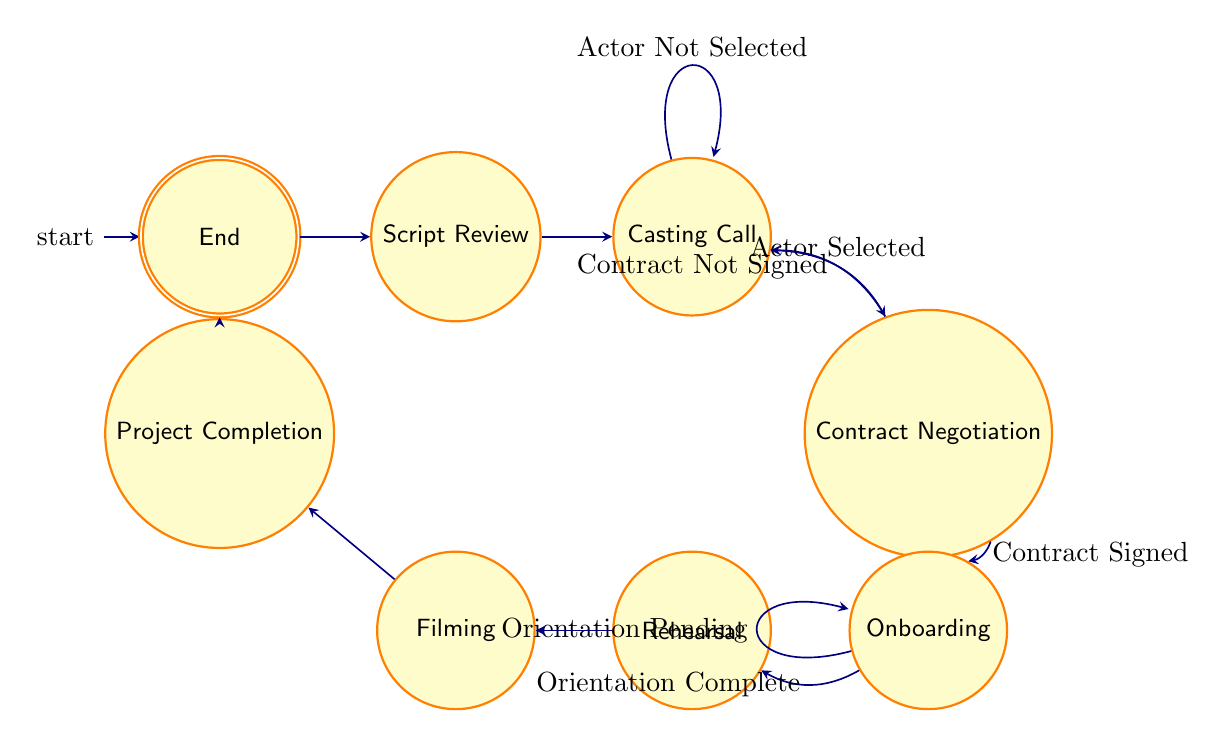What's the initial state of the diagram? The first state listed in the data is "Start", which is indicated as the initial state of the Finite State Machine.
Answer: Start How many states are represented in the diagram? By counting the listed states in the data, there are a total of 8 unique states, including the initial and final states.
Answer: 8 What condition leads to "Contract Negotiation"? The condition that leads to "Contract Negotiation" is "Actor Selected", which comes from the "Casting Call" state.
Answer: Actor Selected What happens if the contract is not signed? If the contract is not signed, the diagram indicates a transition back to the "Casting Call" state from "Contract Negotiation".
Answer: Casting Call What is the next state after "Onboarding" if orientation is complete? If the orientation is complete, the next transition from "Onboarding" is to the "Rehearsal" state.
Answer: Rehearsal How many transitions are there from "Casting Call"? There are two transitions defined from "Casting Call": one when an actor is selected and one that loops back if no actor is selected.
Answer: 2 Which state is the final one in the process? The final state in the process, as indicated in the diagram, is "End".
Answer: End If an actor is selected, what state follows after "Casting Call"? If an actor is selected after "Casting Call", the next state reached is "Contract Negotiation".
Answer: Contract Negotiation What condition leads to the "Project Completion" state? The state "Filming" transitions to "Project Completion" as per the progression defined in the diagram.
Answer: Filming 